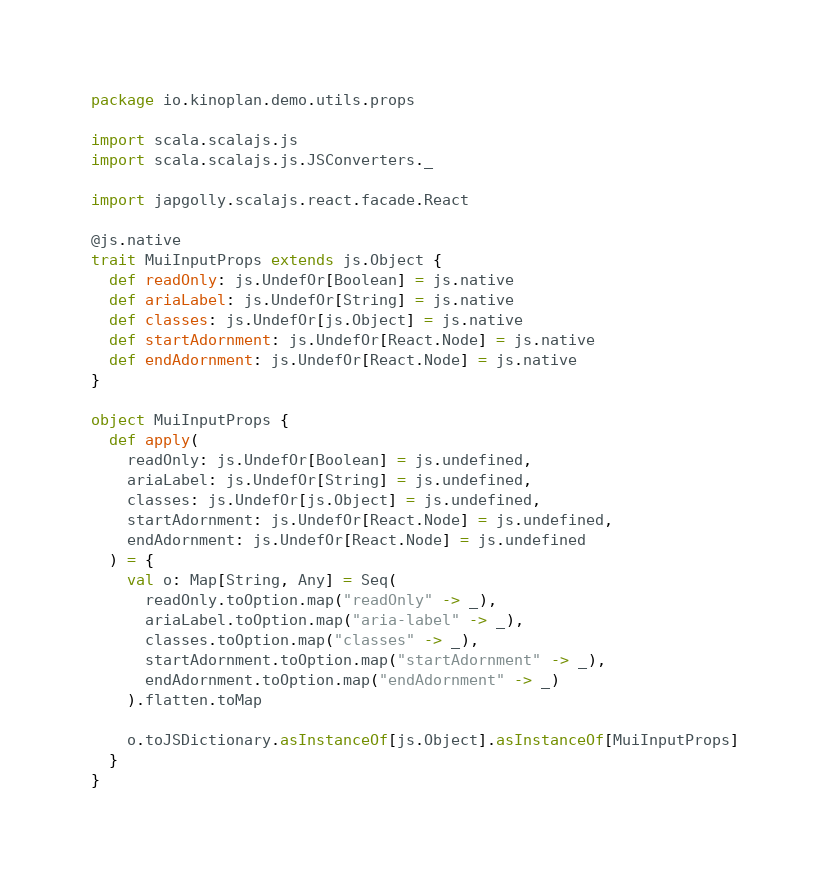Convert code to text. <code><loc_0><loc_0><loc_500><loc_500><_Scala_>package io.kinoplan.demo.utils.props

import scala.scalajs.js
import scala.scalajs.js.JSConverters._

import japgolly.scalajs.react.facade.React

@js.native
trait MuiInputProps extends js.Object {
  def readOnly: js.UndefOr[Boolean] = js.native
  def ariaLabel: js.UndefOr[String] = js.native
  def classes: js.UndefOr[js.Object] = js.native
  def startAdornment: js.UndefOr[React.Node] = js.native
  def endAdornment: js.UndefOr[React.Node] = js.native
}

object MuiInputProps {
  def apply(
    readOnly: js.UndefOr[Boolean] = js.undefined,
    ariaLabel: js.UndefOr[String] = js.undefined,
    classes: js.UndefOr[js.Object] = js.undefined,
    startAdornment: js.UndefOr[React.Node] = js.undefined,
    endAdornment: js.UndefOr[React.Node] = js.undefined
  ) = {
    val o: Map[String, Any] = Seq(
      readOnly.toOption.map("readOnly" -> _),
      ariaLabel.toOption.map("aria-label" -> _),
      classes.toOption.map("classes" -> _),
      startAdornment.toOption.map("startAdornment" -> _),
      endAdornment.toOption.map("endAdornment" -> _)
    ).flatten.toMap

    o.toJSDictionary.asInstanceOf[js.Object].asInstanceOf[MuiInputProps]
  }
}
</code> 